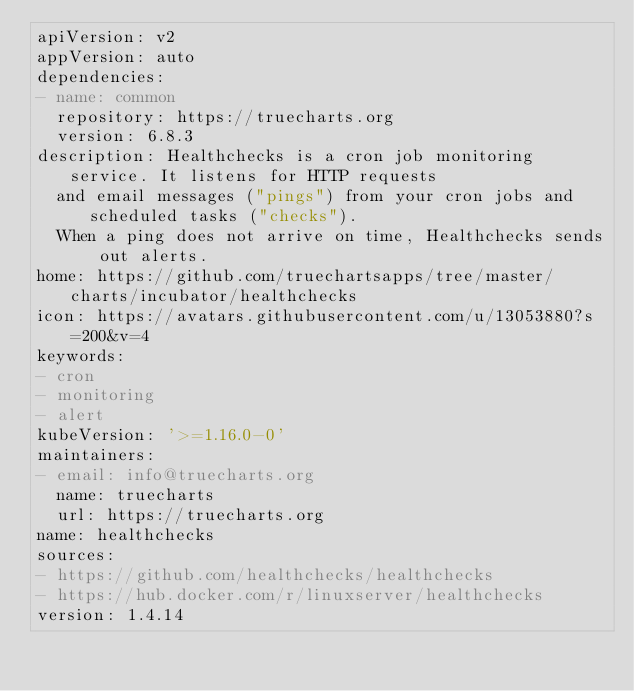<code> <loc_0><loc_0><loc_500><loc_500><_YAML_>apiVersion: v2
appVersion: auto
dependencies:
- name: common
  repository: https://truecharts.org
  version: 6.8.3
description: Healthchecks is a cron job monitoring service. It listens for HTTP requests
  and email messages ("pings") from your cron jobs and scheduled tasks ("checks").
  When a ping does not arrive on time, Healthchecks sends out alerts.
home: https://github.com/truechartsapps/tree/master/charts/incubator/healthchecks
icon: https://avatars.githubusercontent.com/u/13053880?s=200&v=4
keywords:
- cron
- monitoring
- alert
kubeVersion: '>=1.16.0-0'
maintainers:
- email: info@truecharts.org
  name: truecharts
  url: https://truecharts.org
name: healthchecks
sources:
- https://github.com/healthchecks/healthchecks
- https://hub.docker.com/r/linuxserver/healthchecks
version: 1.4.14
</code> 